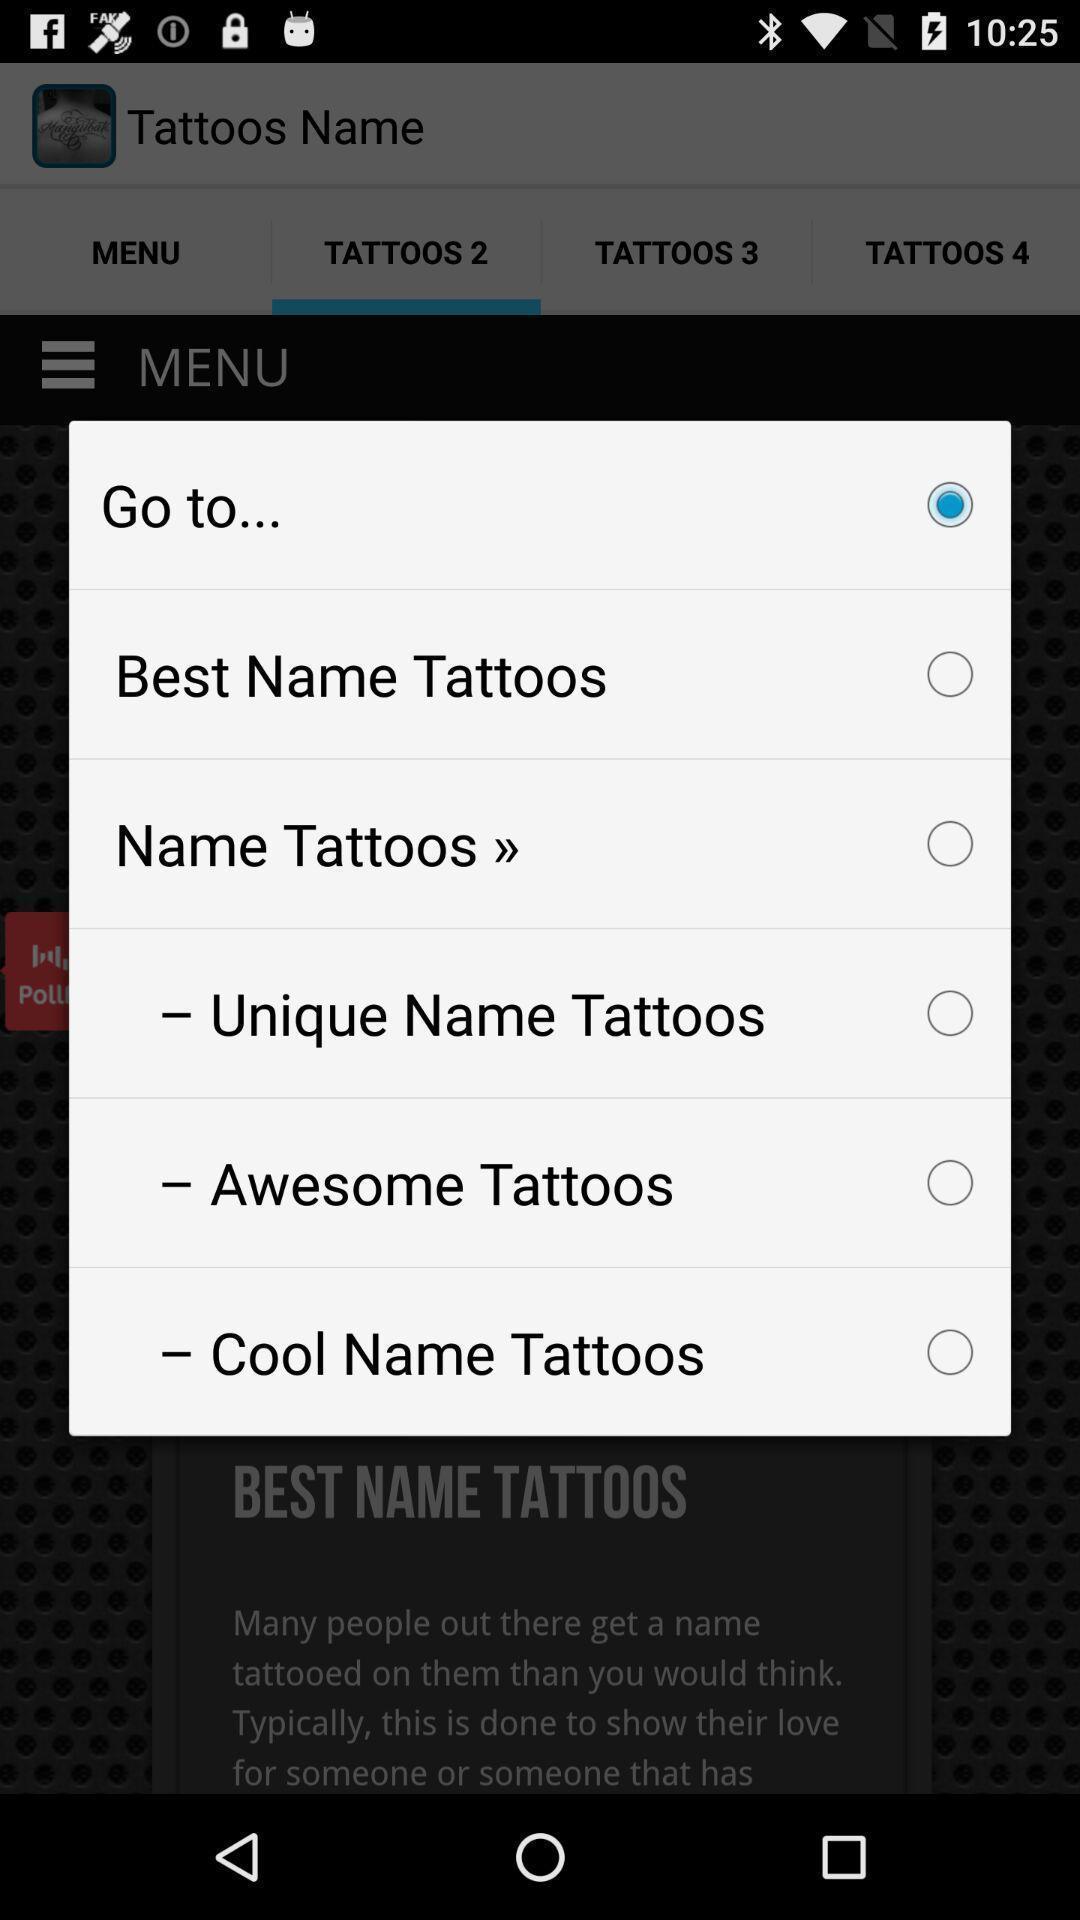Describe the key features of this screenshot. Pop-up to select the tattoo. 